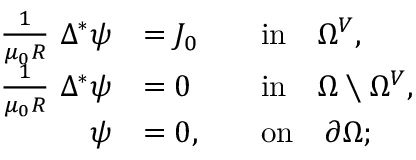<formula> <loc_0><loc_0><loc_500><loc_500>\begin{array} { r l r l } { \frac { 1 } { \mu _ { 0 } R } \Delta ^ { * } \psi } & { = J _ { 0 } } & & { i n \quad \Omega ^ { V } , } \\ { \frac { 1 } { \mu _ { 0 } R } \Delta ^ { * } \psi } & { = 0 } & & { i n \quad \Omega \ \Omega ^ { V } , } \\ { \psi } & { = 0 , } & & { o n \quad \partial \Omega ; } \end{array}</formula> 